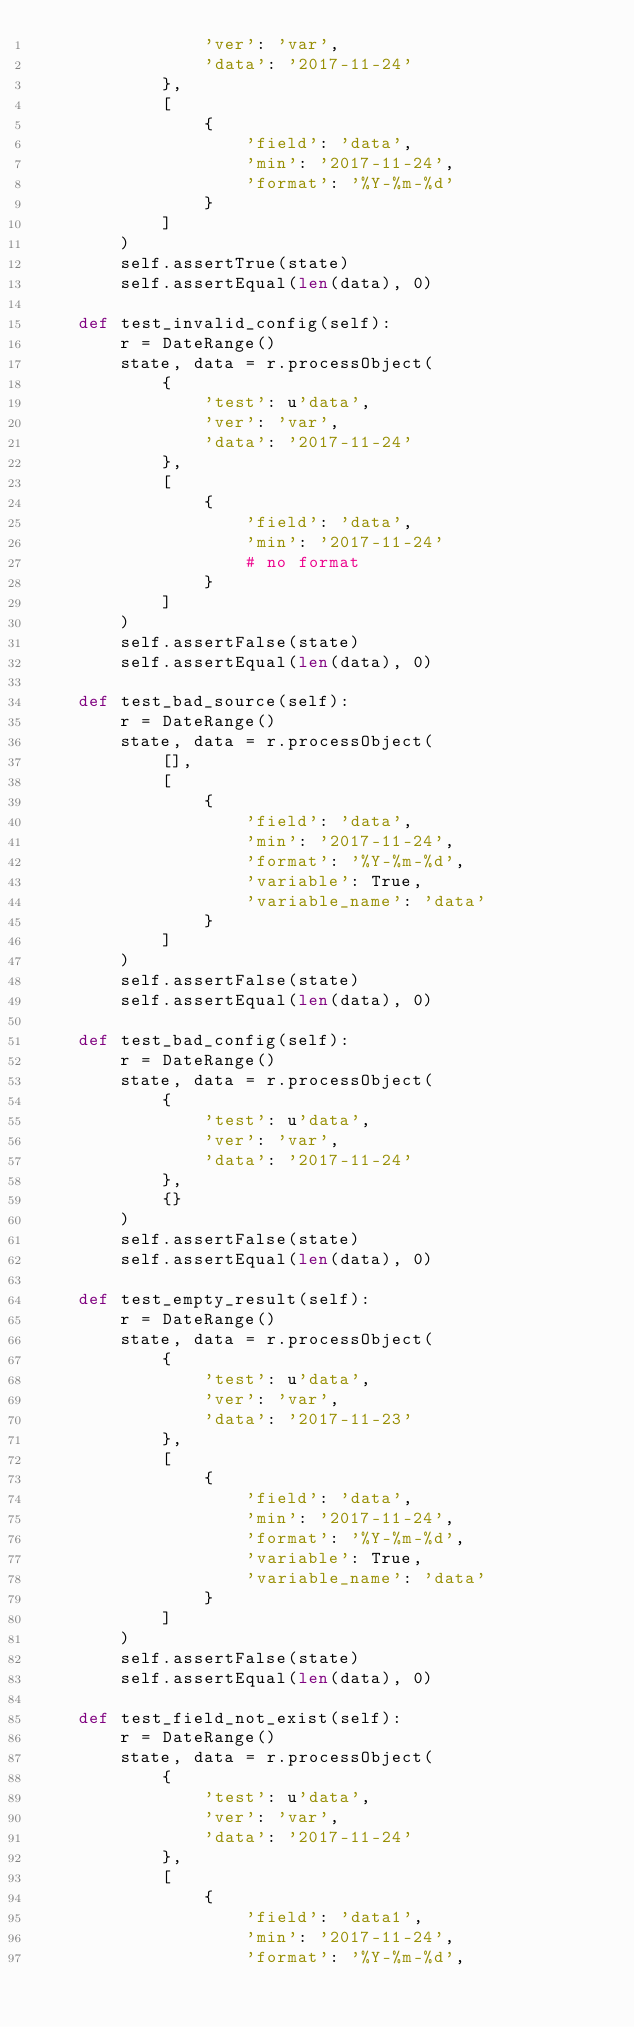<code> <loc_0><loc_0><loc_500><loc_500><_Python_>                'ver': 'var',
                'data': '2017-11-24'
            },
            [
                {
                    'field': 'data',
                    'min': '2017-11-24',
                    'format': '%Y-%m-%d'
                }
            ]
        )
        self.assertTrue(state)
        self.assertEqual(len(data), 0)

    def test_invalid_config(self):
        r = DateRange()
        state, data = r.processObject(
            {
                'test': u'data',
                'ver': 'var',
                'data': '2017-11-24'
            },
            [
                {
                    'field': 'data',
                    'min': '2017-11-24'
                    # no format
                }
            ]
        )
        self.assertFalse(state)
        self.assertEqual(len(data), 0)

    def test_bad_source(self):
        r = DateRange()
        state, data = r.processObject(
            [],
            [
                {
                    'field': 'data',
                    'min': '2017-11-24',
                    'format': '%Y-%m-%d',
                    'variable': True,
                    'variable_name': 'data'
                }
            ]
        )
        self.assertFalse(state)
        self.assertEqual(len(data), 0)

    def test_bad_config(self):
        r = DateRange()
        state, data = r.processObject(
            {
                'test': u'data',
                'ver': 'var',
                'data': '2017-11-24'
            },
            {}
        )
        self.assertFalse(state)
        self.assertEqual(len(data), 0)

    def test_empty_result(self):
        r = DateRange()
        state, data = r.processObject(
            {
                'test': u'data',
                'ver': 'var',
                'data': '2017-11-23'
            },
            [
                {
                    'field': 'data',
                    'min': '2017-11-24',
                    'format': '%Y-%m-%d',
                    'variable': True,
                    'variable_name': 'data'
                }
            ]
        )
        self.assertFalse(state)
        self.assertEqual(len(data), 0)

    def test_field_not_exist(self):
        r = DateRange()
        state, data = r.processObject(
            {
                'test': u'data',
                'ver': 'var',
                'data': '2017-11-24'
            },
            [
                {
                    'field': 'data1',
                    'min': '2017-11-24',
                    'format': '%Y-%m-%d',</code> 